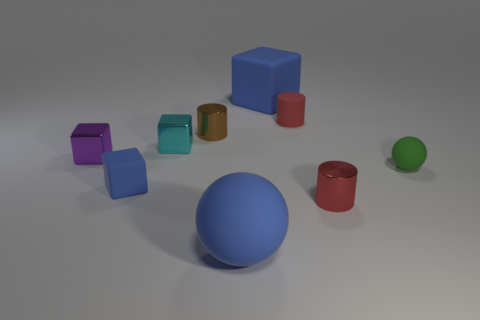Are there the same number of cyan metallic blocks in front of the large rubber block and small balls that are behind the small blue matte thing? After carefully inspecting the image, it seems that there are indeed an equal number of cyan metallic blocks in front of the large rubber block as there are small balls behind the small blue matte object. In both cases, this number is one, which suggests a balanced composition in the arrangement of these objects. 